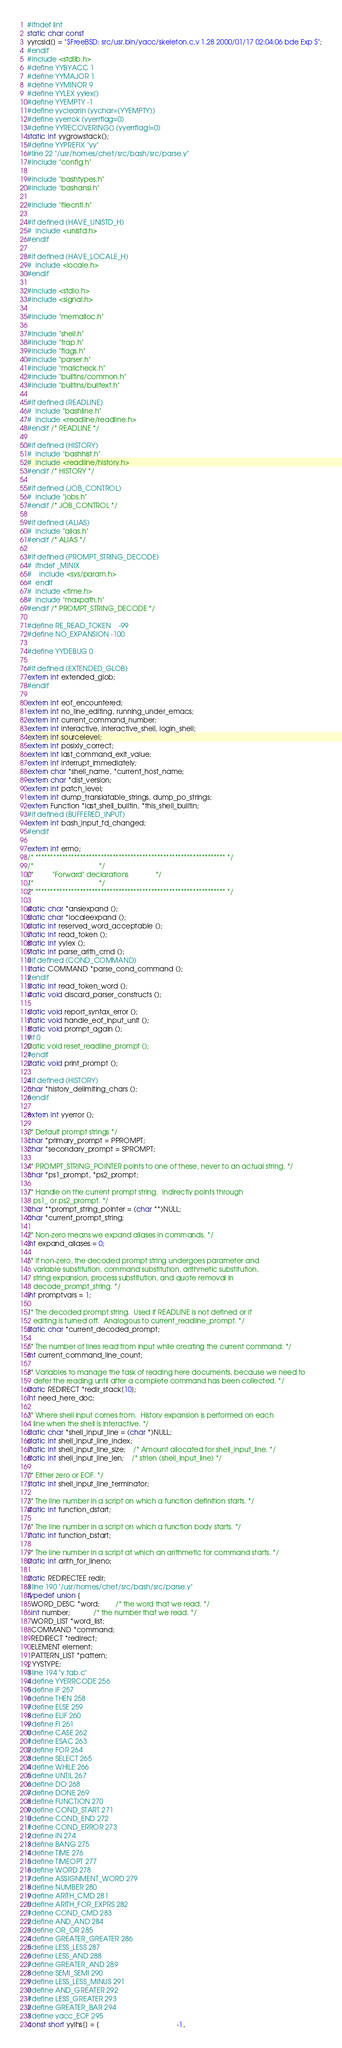<code> <loc_0><loc_0><loc_500><loc_500><_C_>#ifndef lint
static char const 
yyrcsid[] = "$FreeBSD: src/usr.bin/yacc/skeleton.c,v 1.28 2000/01/17 02:04:06 bde Exp $";
#endif
#include <stdlib.h>
#define YYBYACC 1
#define YYMAJOR 1
#define YYMINOR 9
#define YYLEX yylex()
#define YYEMPTY -1
#define yyclearin (yychar=(YYEMPTY))
#define yyerrok (yyerrflag=0)
#define YYRECOVERING() (yyerrflag!=0)
static int yygrowstack();
#define YYPREFIX "yy"
#line 22 "/usr/homes/chet/src/bash/src/parse.y"
#include "config.h"

#include "bashtypes.h"
#include "bashansi.h"

#include "filecntl.h"

#if defined (HAVE_UNISTD_H)
#  include <unistd.h>
#endif

#if defined (HAVE_LOCALE_H)
#  include <locale.h>
#endif

#include <stdio.h>
#include <signal.h>

#include "memalloc.h"

#include "shell.h"
#include "trap.h"
#include "flags.h"
#include "parser.h"
#include "mailcheck.h"
#include "builtins/common.h"
#include "builtins/builtext.h"

#if defined (READLINE)
#  include "bashline.h"
#  include <readline/readline.h>
#endif /* READLINE */

#if defined (HISTORY)
#  include "bashhist.h"
#  include <readline/history.h>
#endif /* HISTORY */

#if defined (JOB_CONTROL)
#  include "jobs.h"
#endif /* JOB_CONTROL */

#if defined (ALIAS)
#  include "alias.h"
#endif /* ALIAS */

#if defined (PROMPT_STRING_DECODE)
#  ifndef _MINIX
#    include <sys/param.h>
#  endif
#  include <time.h>
#  include "maxpath.h"
#endif /* PROMPT_STRING_DECODE */

#define RE_READ_TOKEN	-99
#define NO_EXPANSION	-100

#define YYDEBUG 0

#if defined (EXTENDED_GLOB)
extern int extended_glob;
#endif

extern int eof_encountered;
extern int no_line_editing, running_under_emacs;
extern int current_command_number;
extern int interactive, interactive_shell, login_shell;
extern int sourcelevel;
extern int posixly_correct;
extern int last_command_exit_value;
extern int interrupt_immediately;
extern char *shell_name, *current_host_name;
extern char *dist_version;
extern int patch_level;
extern int dump_translatable_strings, dump_po_strings;
extern Function *last_shell_builtin, *this_shell_builtin;
#if defined (BUFFERED_INPUT)
extern int bash_input_fd_changed;
#endif

extern int errno;
/* **************************************************************** */
/*								    */
/*		    "Forward" declarations			    */
/*								    */
/* **************************************************************** */

static char *ansiexpand ();
static char *localeexpand ();
static int reserved_word_acceptable ();
static int read_token ();
static int yylex ();
static int parse_arith_cmd ();
#if defined (COND_COMMAND)
static COMMAND *parse_cond_command ();
#endif
static int read_token_word ();
static void discard_parser_constructs ();

static void report_syntax_error ();
static void handle_eof_input_unit ();
static void prompt_again ();
#if 0
static void reset_readline_prompt ();
#endif
static void print_prompt ();

#if defined (HISTORY)
char *history_delimiting_chars ();
#endif

extern int yyerror ();

/* Default prompt strings */
char *primary_prompt = PPROMPT;
char *secondary_prompt = SPROMPT;

/* PROMPT_STRING_POINTER points to one of these, never to an actual string. */
char *ps1_prompt, *ps2_prompt;

/* Handle on the current prompt string.  Indirectly points through
   ps1_ or ps2_prompt. */
char **prompt_string_pointer = (char **)NULL;
char *current_prompt_string;

/* Non-zero means we expand aliases in commands. */
int expand_aliases = 0;

/* If non-zero, the decoded prompt string undergoes parameter and
   variable substitution, command substitution, arithmetic substitution,
   string expansion, process substitution, and quote removal in
   decode_prompt_string. */
int promptvars = 1;

/* The decoded prompt string.  Used if READLINE is not defined or if
   editing is turned off.  Analogous to current_readline_prompt. */
static char *current_decoded_prompt;

/* The number of lines read from input while creating the current command. */
int current_command_line_count;

/* Variables to manage the task of reading here documents, because we need to
   defer the reading until after a complete command has been collected. */
static REDIRECT *redir_stack[10];
int need_here_doc;

/* Where shell input comes from.  History expansion is performed on each
   line when the shell is interactive. */
static char *shell_input_line = (char *)NULL;
static int shell_input_line_index;
static int shell_input_line_size;	/* Amount allocated for shell_input_line. */
static int shell_input_line_len;	/* strlen (shell_input_line) */

/* Either zero or EOF. */
static int shell_input_line_terminator;

/* The line number in a script on which a function definition starts. */
static int function_dstart;

/* The line number in a script on which a function body starts. */
static int function_bstart;

/* The line number in a script at which an arithmetic for command starts. */
static int arith_for_lineno;

static REDIRECTEE redir;
#line 190 "/usr/homes/chet/src/bash/src/parse.y"
typedef union {
  WORD_DESC *word;		/* the word that we read. */
  int number;			/* the number that we read. */
  WORD_LIST *word_list;
  COMMAND *command;
  REDIRECT *redirect;
  ELEMENT element;
  PATTERN_LIST *pattern;
} YYSTYPE;
#line 194 "y.tab.c"
#define YYERRCODE 256
#define IF 257
#define THEN 258
#define ELSE 259
#define ELIF 260
#define FI 261
#define CASE 262
#define ESAC 263
#define FOR 264
#define SELECT 265
#define WHILE 266
#define UNTIL 267
#define DO 268
#define DONE 269
#define FUNCTION 270
#define COND_START 271
#define COND_END 272
#define COND_ERROR 273
#define IN 274
#define BANG 275
#define TIME 276
#define TIMEOPT 277
#define WORD 278
#define ASSIGNMENT_WORD 279
#define NUMBER 280
#define ARITH_CMD 281
#define ARITH_FOR_EXPRS 282
#define COND_CMD 283
#define AND_AND 284
#define OR_OR 285
#define GREATER_GREATER 286
#define LESS_LESS 287
#define LESS_AND 288
#define GREATER_AND 289
#define SEMI_SEMI 290
#define LESS_LESS_MINUS 291
#define AND_GREATER 292
#define LESS_GREATER 293
#define GREATER_BAR 294
#define yacc_EOF 295
const short yylhs[] = {                                        -1,</code> 